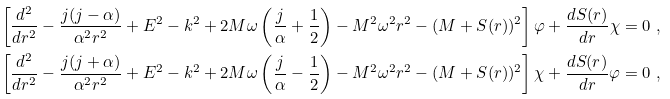Convert formula to latex. <formula><loc_0><loc_0><loc_500><loc_500>\left [ \frac { d ^ { 2 } } { d r ^ { 2 } } - \frac { j ( j - \alpha ) } { \alpha ^ { 2 } r ^ { 2 } } + E ^ { 2 } - k ^ { 2 } + 2 M \omega \left ( \frac { j } { \alpha } + \frac { 1 } { 2 } \right ) - M ^ { 2 } \omega ^ { 2 } r ^ { 2 } - ( M + S ( r ) ) ^ { 2 } \right ] \varphi + \frac { d S ( r ) } { d r } \chi & = 0 \ , \\ \left [ \frac { d ^ { 2 } } { d r ^ { 2 } } - \frac { j ( j + \alpha ) } { \alpha ^ { 2 } r ^ { 2 } } + E ^ { 2 } - k ^ { 2 } + 2 M \omega \left ( \frac { j } { \alpha } - \frac { 1 } { 2 } \right ) - M ^ { 2 } \omega ^ { 2 } r ^ { 2 } - ( M + S ( r ) ) ^ { 2 } \right ] \chi + \frac { d S ( r ) } { d r } \varphi & = 0 \ ,</formula> 